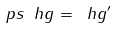<formula> <loc_0><loc_0><loc_500><loc_500>\ p s \ h g = \ h g ^ { \prime }</formula> 